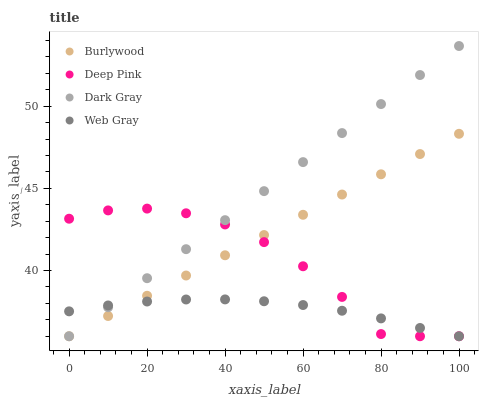Does Web Gray have the minimum area under the curve?
Answer yes or no. Yes. Does Dark Gray have the maximum area under the curve?
Answer yes or no. Yes. Does Deep Pink have the minimum area under the curve?
Answer yes or no. No. Does Deep Pink have the maximum area under the curve?
Answer yes or no. No. Is Dark Gray the smoothest?
Answer yes or no. Yes. Is Deep Pink the roughest?
Answer yes or no. Yes. Is Deep Pink the smoothest?
Answer yes or no. No. Is Dark Gray the roughest?
Answer yes or no. No. Does Burlywood have the lowest value?
Answer yes or no. Yes. Does Dark Gray have the highest value?
Answer yes or no. Yes. Does Deep Pink have the highest value?
Answer yes or no. No. Does Burlywood intersect Web Gray?
Answer yes or no. Yes. Is Burlywood less than Web Gray?
Answer yes or no. No. Is Burlywood greater than Web Gray?
Answer yes or no. No. 